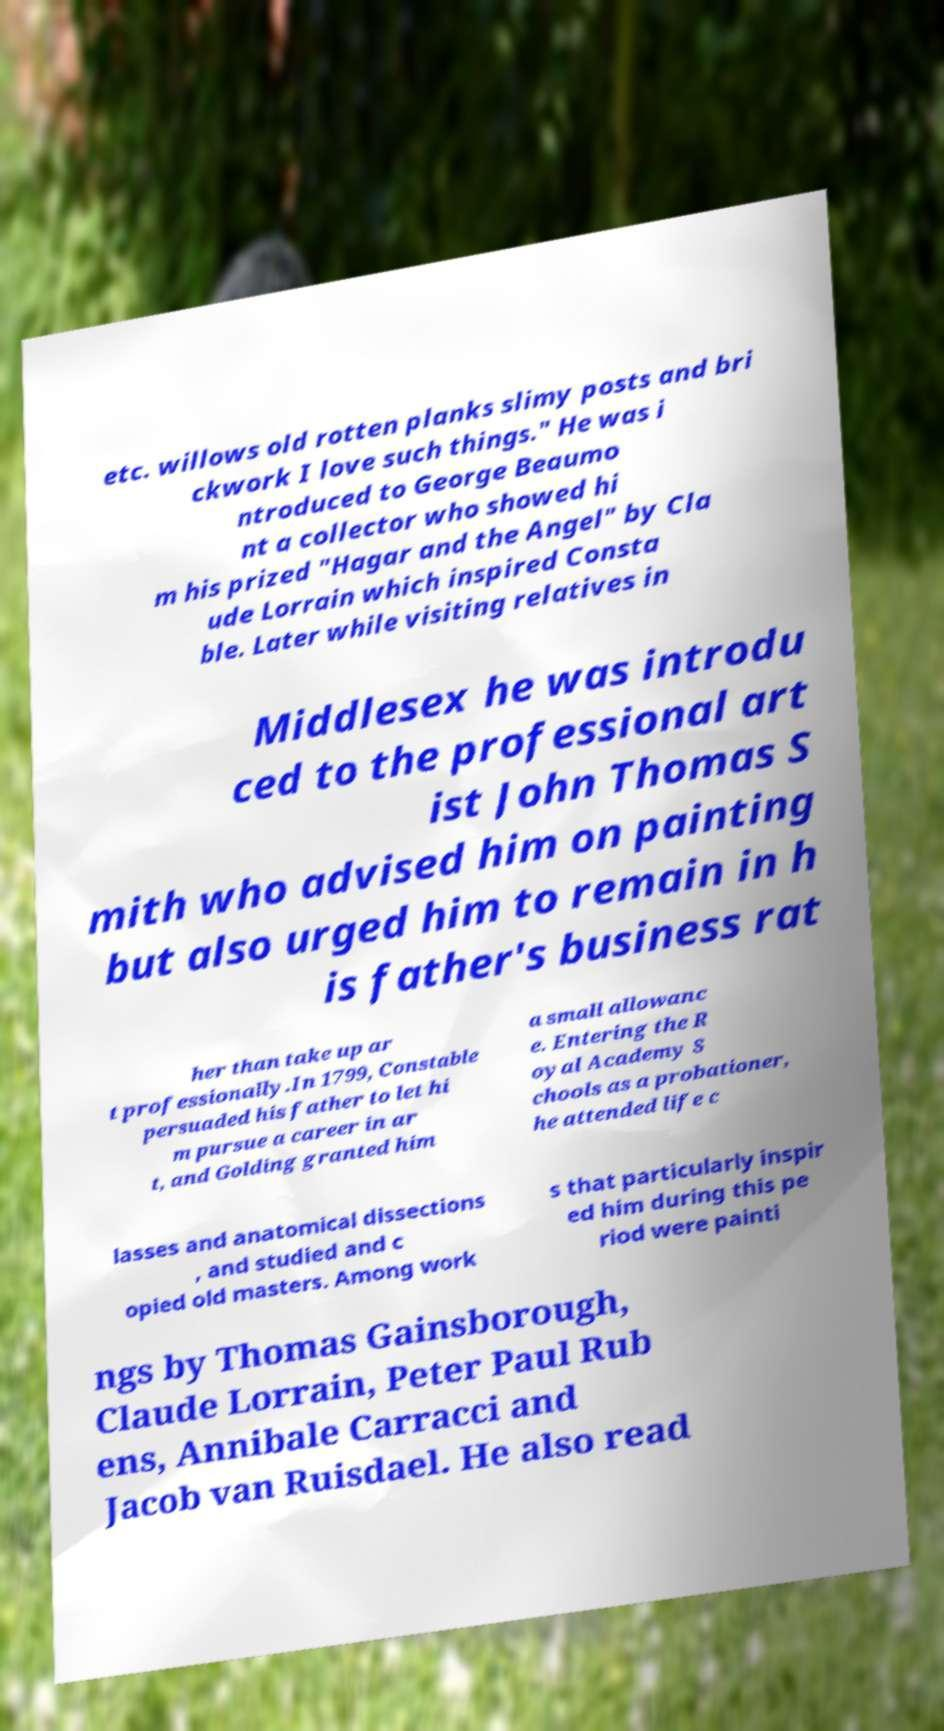For documentation purposes, I need the text within this image transcribed. Could you provide that? etc. willows old rotten planks slimy posts and bri ckwork I love such things." He was i ntroduced to George Beaumo nt a collector who showed hi m his prized "Hagar and the Angel" by Cla ude Lorrain which inspired Consta ble. Later while visiting relatives in Middlesex he was introdu ced to the professional art ist John Thomas S mith who advised him on painting but also urged him to remain in h is father's business rat her than take up ar t professionally.In 1799, Constable persuaded his father to let hi m pursue a career in ar t, and Golding granted him a small allowanc e. Entering the R oyal Academy S chools as a probationer, he attended life c lasses and anatomical dissections , and studied and c opied old masters. Among work s that particularly inspir ed him during this pe riod were painti ngs by Thomas Gainsborough, Claude Lorrain, Peter Paul Rub ens, Annibale Carracci and Jacob van Ruisdael. He also read 